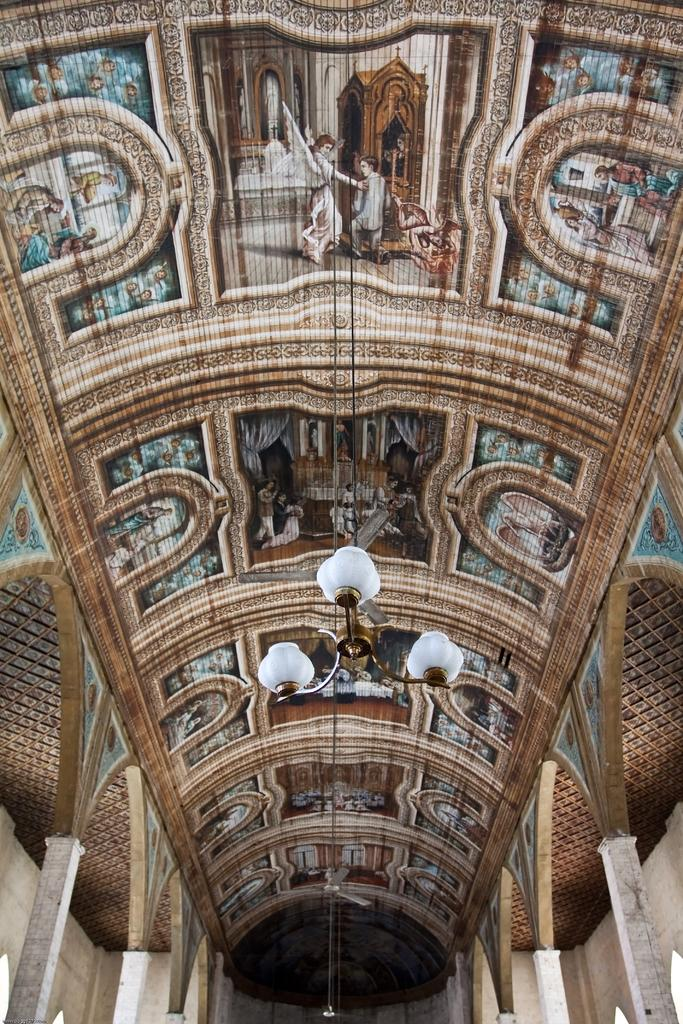What is present on top of the structure in the image? There is a roof in the image. What can be seen on the roof? There are paintings and a light on the roof. What type of silk is being used to create the paintings on the roof? There is no mention of silk or any specific material used for the paintings in the image. 